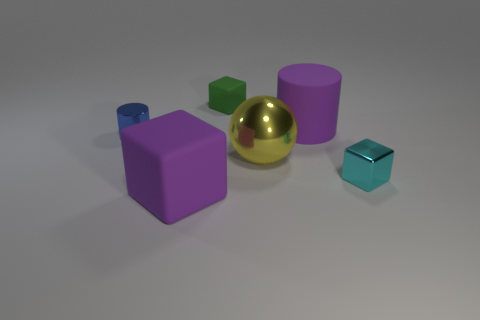What material is the tiny green cube? Based on the image, the tiny green cube appears to have a matte finish, suggesting it could be made of a material like plastic or painted wood, rather than rubber which typically has a more shiny texture. Without being able to feel the weight or texture, it isn't possible to definitively determine the material from visuals alone. 